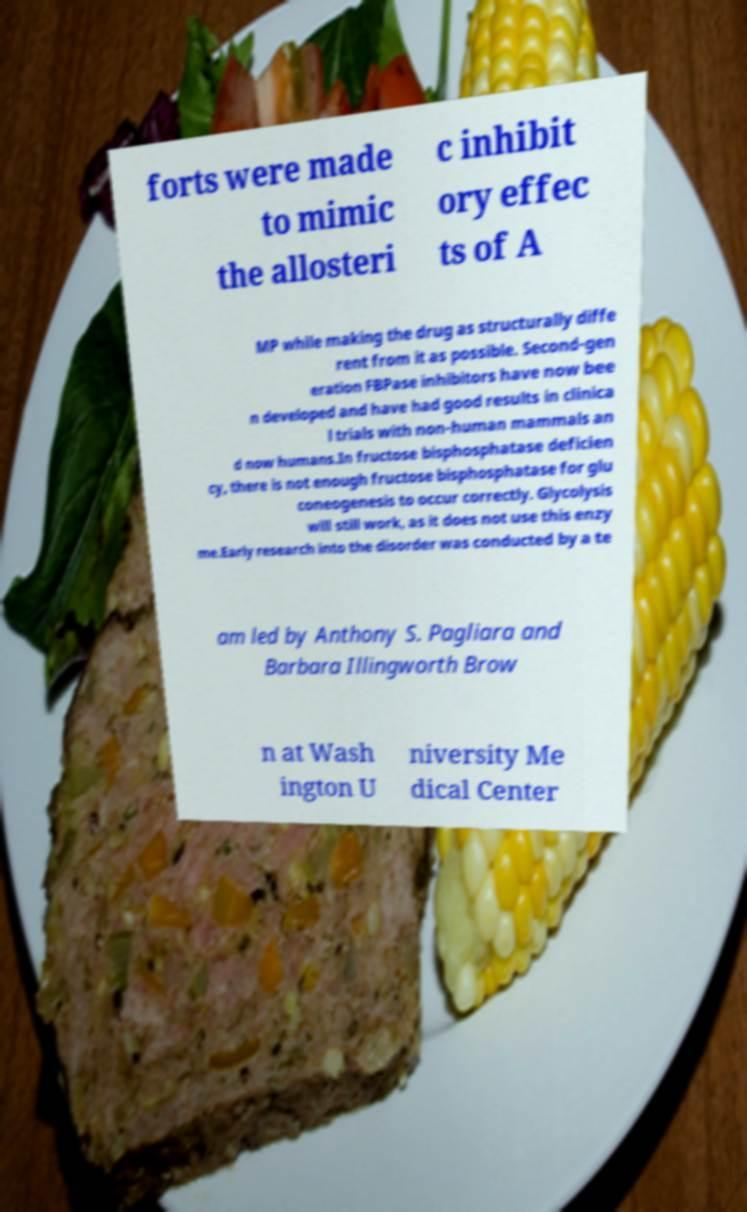Can you read and provide the text displayed in the image?This photo seems to have some interesting text. Can you extract and type it out for me? forts were made to mimic the allosteri c inhibit ory effec ts of A MP while making the drug as structurally diffe rent from it as possible. Second-gen eration FBPase inhibitors have now bee n developed and have had good results in clinica l trials with non-human mammals an d now humans.In fructose bisphosphatase deficien cy, there is not enough fructose bisphosphatase for glu coneogenesis to occur correctly. Glycolysis will still work, as it does not use this enzy me.Early research into the disorder was conducted by a te am led by Anthony S. Pagliara and Barbara Illingworth Brow n at Wash ington U niversity Me dical Center 